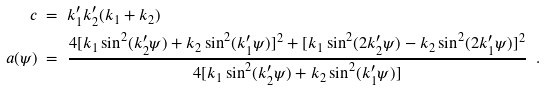<formula> <loc_0><loc_0><loc_500><loc_500>c & \ = \ k ^ { \prime } _ { 1 } k ^ { \prime } _ { 2 } ( k _ { 1 } + k _ { 2 } ) \\ a ( \psi ) & \ = \ \frac { 4 [ k _ { 1 } \sin ^ { 2 } ( k ^ { \prime } _ { 2 } \psi ) + k _ { 2 } \sin ^ { 2 } ( k ^ { \prime } _ { 1 } \psi ) ] ^ { 2 } + [ k _ { 1 } \sin ^ { 2 } ( 2 k ^ { \prime } _ { 2 } \psi ) - k _ { 2 } \sin ^ { 2 } ( 2 k ^ { \prime } _ { 1 } \psi ) ] ^ { 2 } } { 4 [ k _ { 1 } \sin ^ { 2 } ( k ^ { \prime } _ { 2 } \psi ) + k _ { 2 } \sin ^ { 2 } ( k ^ { \prime } _ { 1 } \psi ) ] } \ \ .</formula> 